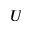<formula> <loc_0><loc_0><loc_500><loc_500>U</formula> 